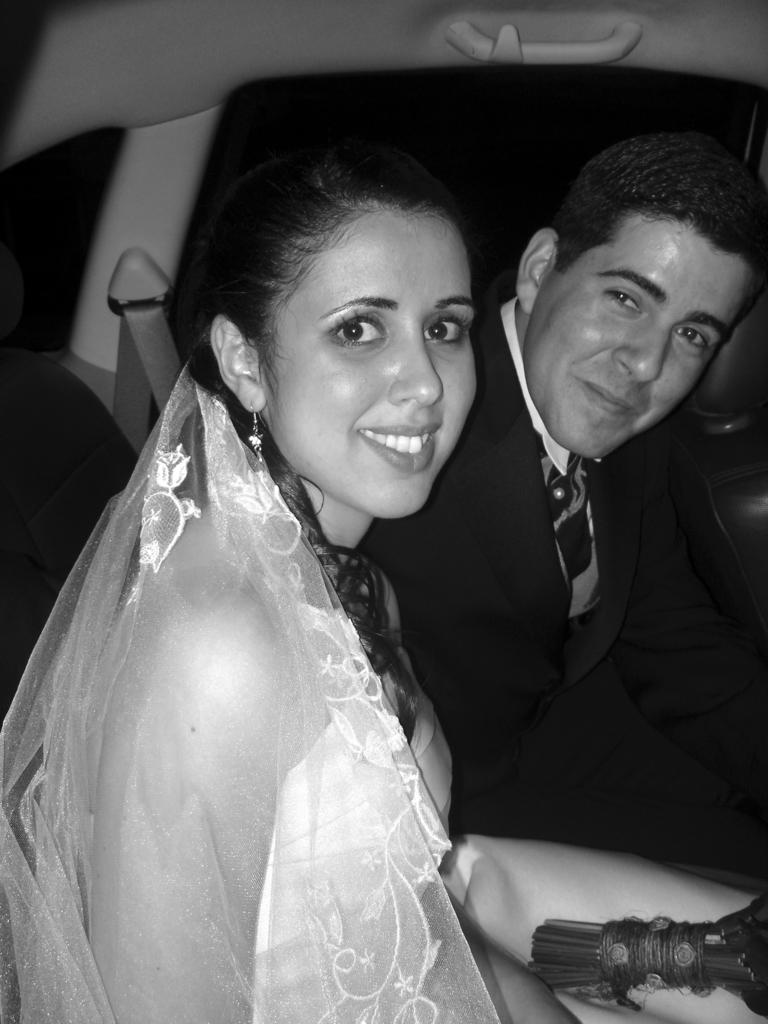How many people are in the image? There are two persons in the image. What are the two persons doing in the image? The two persons are sitting. Where might the image have been taken? The image may have been taken in a vehicle. What is the setting of the image? The image was taken on a road. What scientific experiment is being conducted by the carpenter in the image? There is no scientific experiment or carpenter present in the image. What is the hope of the two persons in the image? The image does not provide any information about the hopes or intentions of the two persons. 